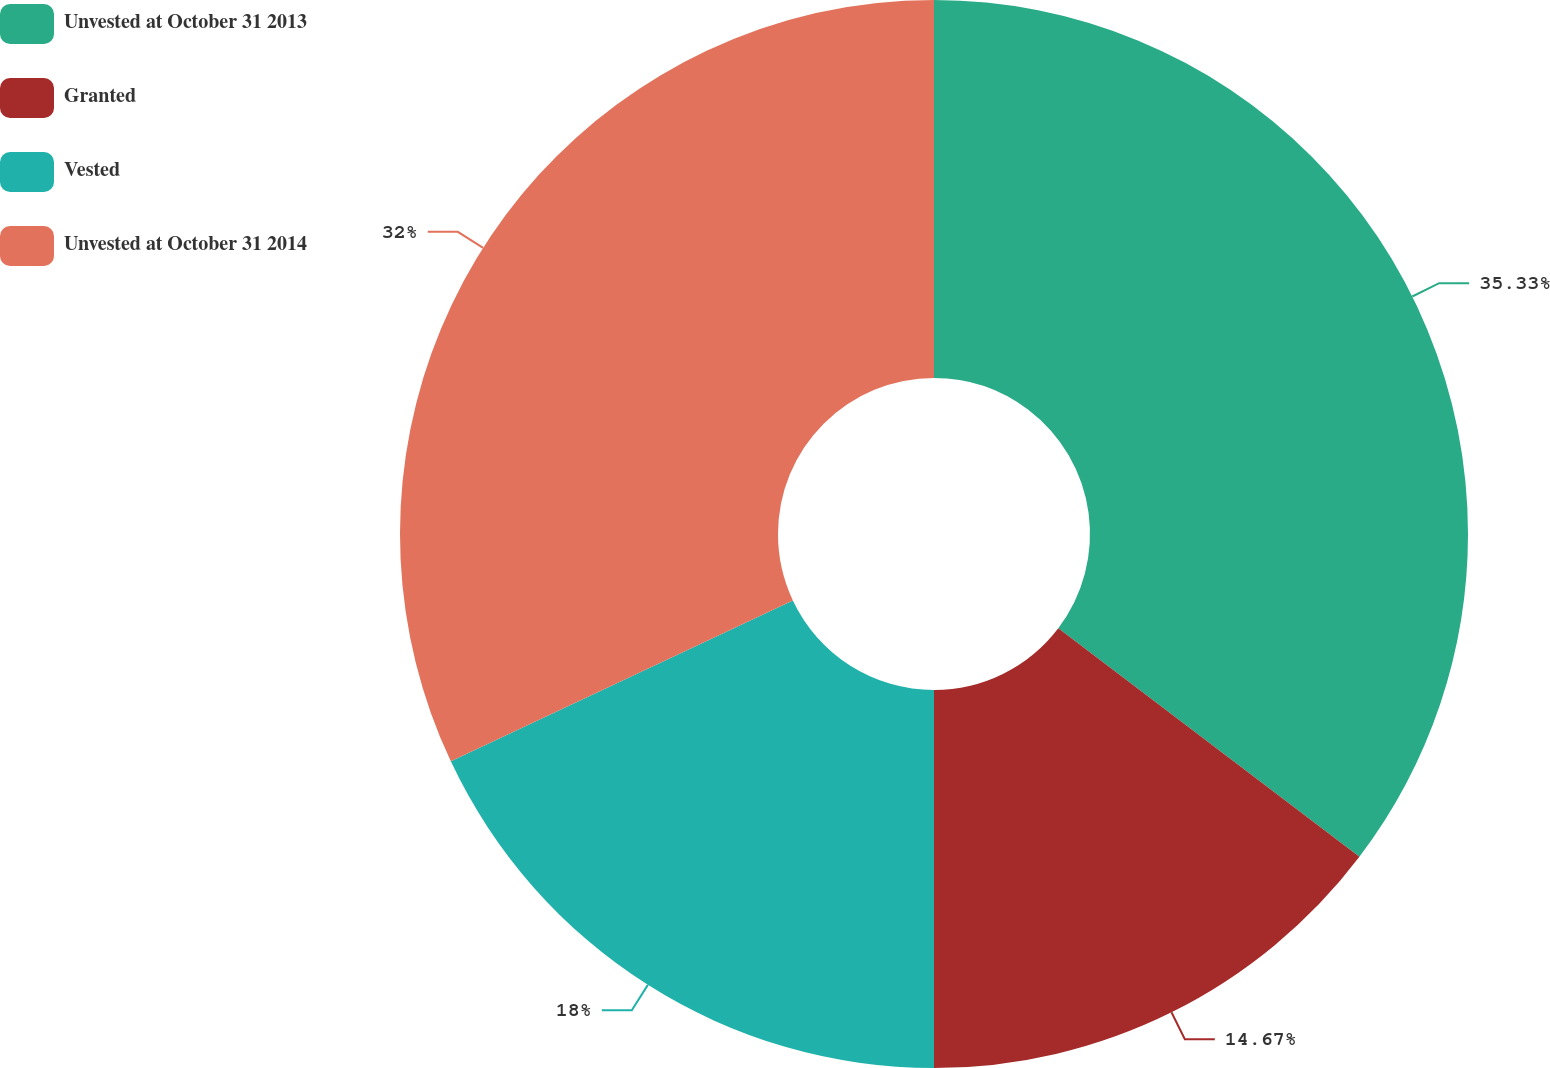Convert chart. <chart><loc_0><loc_0><loc_500><loc_500><pie_chart><fcel>Unvested at October 31 2013<fcel>Granted<fcel>Vested<fcel>Unvested at October 31 2014<nl><fcel>35.33%<fcel>14.67%<fcel>18.0%<fcel>32.0%<nl></chart> 